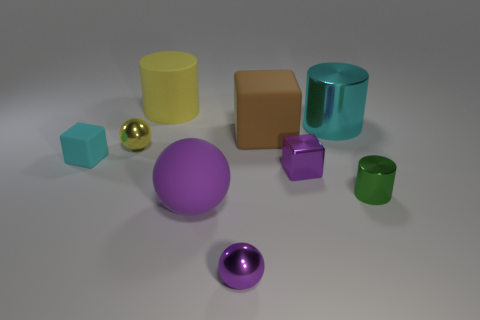Add 1 small cyan rubber blocks. How many objects exist? 10 Subtract all blocks. How many objects are left? 6 Subtract all purple things. Subtract all yellow matte objects. How many objects are left? 5 Add 4 small rubber objects. How many small rubber objects are left? 5 Add 4 tiny cyan metal things. How many tiny cyan metal things exist? 4 Subtract 1 yellow cylinders. How many objects are left? 8 